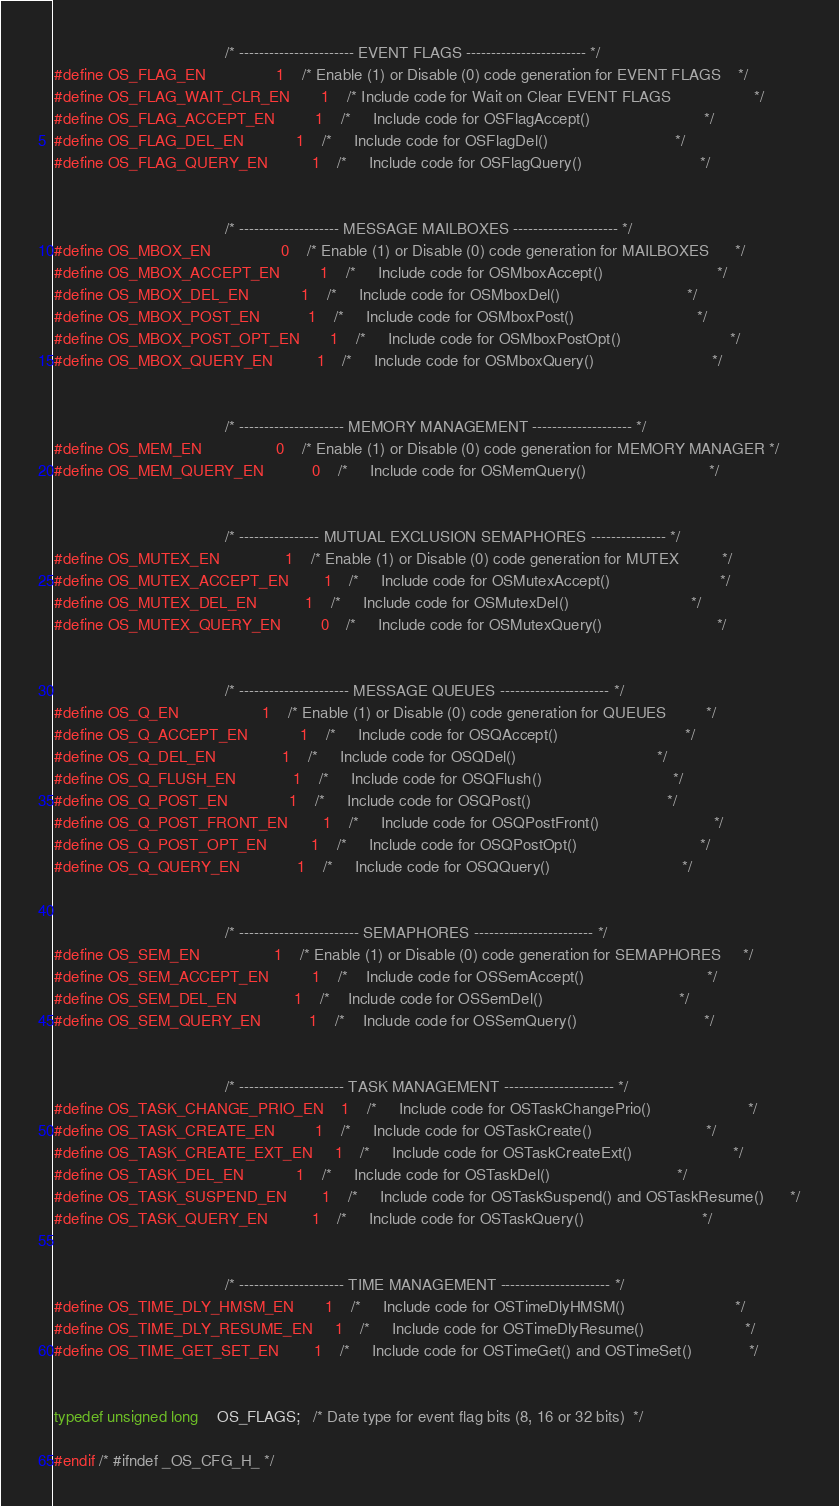Convert code to text. <code><loc_0><loc_0><loc_500><loc_500><_C_>

                                       /* ----------------------- EVENT FLAGS ------------------------ */
#define OS_FLAG_EN                1    /* Enable (1) or Disable (0) code generation for EVENT FLAGS    */
#define OS_FLAG_WAIT_CLR_EN       1    /* Include code for Wait on Clear EVENT FLAGS                   */
#define OS_FLAG_ACCEPT_EN         1    /*     Include code for OSFlagAccept()                          */
#define OS_FLAG_DEL_EN            1    /*     Include code for OSFlagDel()                             */
#define OS_FLAG_QUERY_EN          1    /*     Include code for OSFlagQuery()                           */


                                       /* -------------------- MESSAGE MAILBOXES --------------------- */
#define OS_MBOX_EN                0    /* Enable (1) or Disable (0) code generation for MAILBOXES      */
#define OS_MBOX_ACCEPT_EN         1    /*     Include code for OSMboxAccept()                          */
#define OS_MBOX_DEL_EN            1    /*     Include code for OSMboxDel()                             */
#define OS_MBOX_POST_EN           1    /*     Include code for OSMboxPost()                            */
#define OS_MBOX_POST_OPT_EN       1    /*     Include code for OSMboxPostOpt()                         */
#define OS_MBOX_QUERY_EN          1    /*     Include code for OSMboxQuery()                           */


                                       /* --------------------- MEMORY MANAGEMENT -------------------- */
#define OS_MEM_EN                 0    /* Enable (1) or Disable (0) code generation for MEMORY MANAGER */
#define OS_MEM_QUERY_EN           0    /*     Include code for OSMemQuery()                            */


                                       /* ---------------- MUTUAL EXCLUSION SEMAPHORES --------------- */
#define OS_MUTEX_EN               1    /* Enable (1) or Disable (0) code generation for MUTEX          */
#define OS_MUTEX_ACCEPT_EN        1    /*     Include code for OSMutexAccept()                         */
#define OS_MUTEX_DEL_EN           1    /*     Include code for OSMutexDel()                            */
#define OS_MUTEX_QUERY_EN         0    /*     Include code for OSMutexQuery()                          */


                                       /* ---------------------- MESSAGE QUEUES ---------------------- */
#define OS_Q_EN                   1    /* Enable (1) or Disable (0) code generation for QUEUES         */
#define OS_Q_ACCEPT_EN            1    /*     Include code for OSQAccept()                             */
#define OS_Q_DEL_EN               1    /*     Include code for OSQDel()                                */
#define OS_Q_FLUSH_EN             1    /*     Include code for OSQFlush()                              */
#define OS_Q_POST_EN              1    /*     Include code for OSQPost()                               */
#define OS_Q_POST_FRONT_EN        1    /*     Include code for OSQPostFront()                          */
#define OS_Q_POST_OPT_EN          1    /*     Include code for OSQPostOpt()                            */
#define OS_Q_QUERY_EN             1    /*     Include code for OSQQuery()                              */


                                       /* ------------------------ SEMAPHORES ------------------------ */
#define OS_SEM_EN                 1    /* Enable (1) or Disable (0) code generation for SEMAPHORES     */
#define OS_SEM_ACCEPT_EN          1    /*    Include code for OSSemAccept()                            */
#define OS_SEM_DEL_EN             1    /*    Include code for OSSemDel()                               */
#define OS_SEM_QUERY_EN           1    /*    Include code for OSSemQuery()                             */


                                       /* --------------------- TASK MANAGEMENT ---------------------- */
#define OS_TASK_CHANGE_PRIO_EN    1    /*     Include code for OSTaskChangePrio()                      */
#define OS_TASK_CREATE_EN         1    /*     Include code for OSTaskCreate()                          */
#define OS_TASK_CREATE_EXT_EN     1    /*     Include code for OSTaskCreateExt()                       */
#define OS_TASK_DEL_EN            1    /*     Include code for OSTaskDel()                             */
#define OS_TASK_SUSPEND_EN        1    /*     Include code for OSTaskSuspend() and OSTaskResume()      */
#define OS_TASK_QUERY_EN          1    /*     Include code for OSTaskQuery()                           */


                                       /* --------------------- TIME MANAGEMENT ---------------------- */
#define OS_TIME_DLY_HMSM_EN       1    /*     Include code for OSTimeDlyHMSM()                         */
#define OS_TIME_DLY_RESUME_EN     1    /*     Include code for OSTimeDlyResume()                       */
#define OS_TIME_GET_SET_EN        1    /*     Include code for OSTimeGet() and OSTimeSet()             */


typedef unsigned long    OS_FLAGS;   /* Date type for event flag bits (8, 16 or 32 bits)  */

#endif /* #ifndef _OS_CFG_H_ */
</code> 